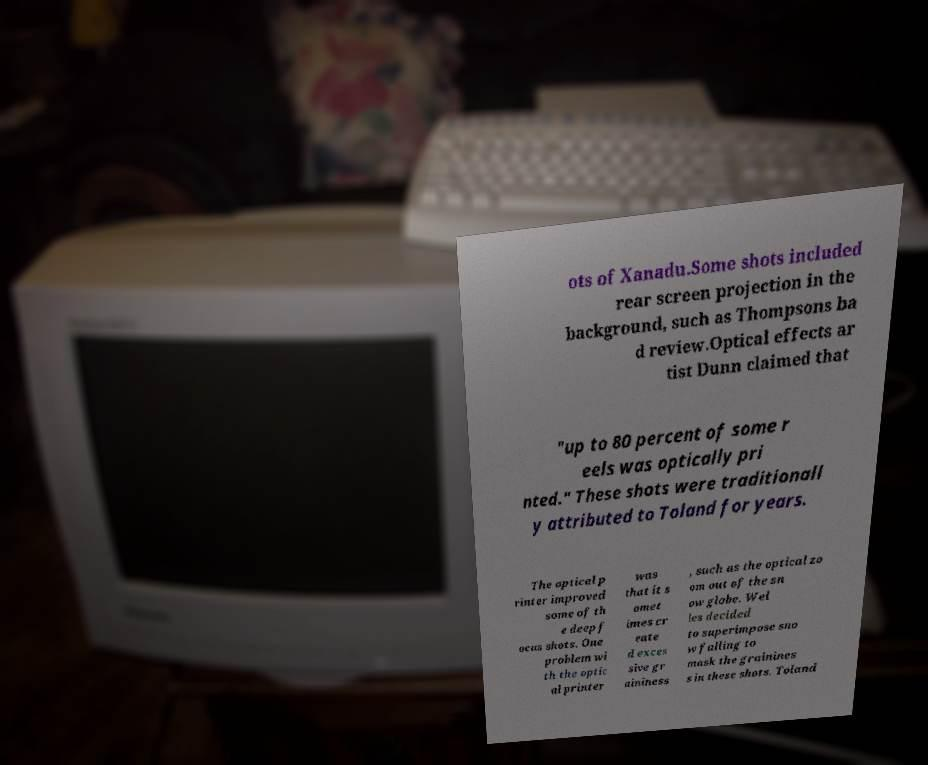I need the written content from this picture converted into text. Can you do that? ots of Xanadu.Some shots included rear screen projection in the background, such as Thompsons ba d review.Optical effects ar tist Dunn claimed that "up to 80 percent of some r eels was optically pri nted." These shots were traditionall y attributed to Toland for years. The optical p rinter improved some of th e deep f ocus shots. One problem wi th the optic al printer was that it s omet imes cr eate d exces sive gr aininess , such as the optical zo om out of the sn ow globe. Wel les decided to superimpose sno w falling to mask the grainines s in these shots. Toland 